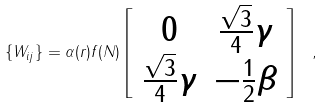Convert formula to latex. <formula><loc_0><loc_0><loc_500><loc_500>\{ W _ { i j } \} = \alpha ( r ) f ( N ) \left [ \begin{array} { c c } 0 & \frac { \sqrt { 3 } } { 4 } \gamma \\ \frac { \sqrt { 3 } } { 4 } \gamma & - \frac { 1 } { 2 } \beta \end{array} \right ] \ ,</formula> 